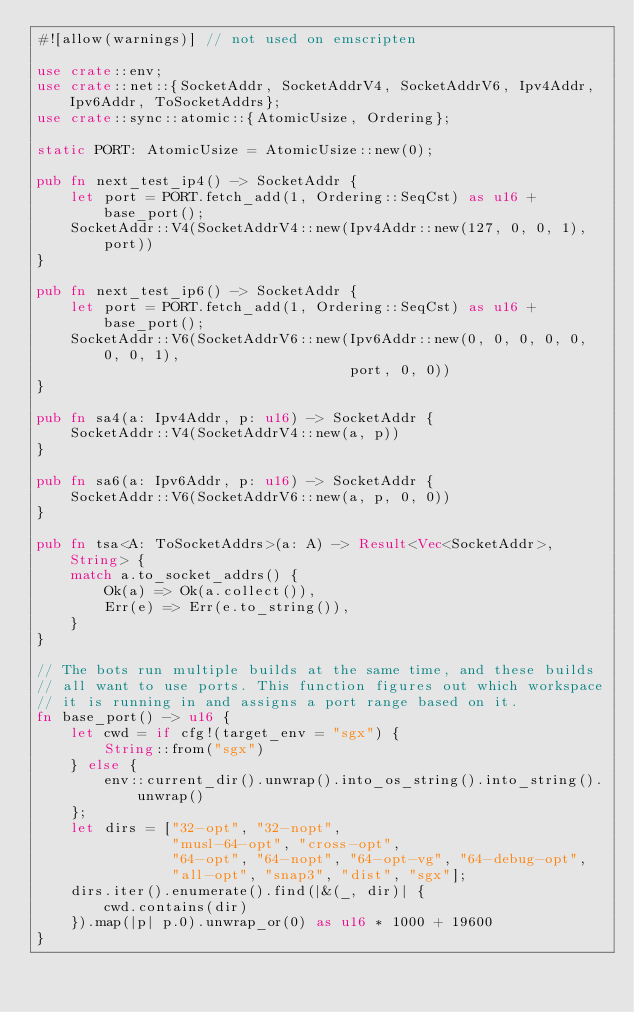Convert code to text. <code><loc_0><loc_0><loc_500><loc_500><_Rust_>#![allow(warnings)] // not used on emscripten

use crate::env;
use crate::net::{SocketAddr, SocketAddrV4, SocketAddrV6, Ipv4Addr, Ipv6Addr, ToSocketAddrs};
use crate::sync::atomic::{AtomicUsize, Ordering};

static PORT: AtomicUsize = AtomicUsize::new(0);

pub fn next_test_ip4() -> SocketAddr {
    let port = PORT.fetch_add(1, Ordering::SeqCst) as u16 + base_port();
    SocketAddr::V4(SocketAddrV4::new(Ipv4Addr::new(127, 0, 0, 1), port))
}

pub fn next_test_ip6() -> SocketAddr {
    let port = PORT.fetch_add(1, Ordering::SeqCst) as u16 + base_port();
    SocketAddr::V6(SocketAddrV6::new(Ipv6Addr::new(0, 0, 0, 0, 0, 0, 0, 1),
                                     port, 0, 0))
}

pub fn sa4(a: Ipv4Addr, p: u16) -> SocketAddr {
    SocketAddr::V4(SocketAddrV4::new(a, p))
}

pub fn sa6(a: Ipv6Addr, p: u16) -> SocketAddr {
    SocketAddr::V6(SocketAddrV6::new(a, p, 0, 0))
}

pub fn tsa<A: ToSocketAddrs>(a: A) -> Result<Vec<SocketAddr>, String> {
    match a.to_socket_addrs() {
        Ok(a) => Ok(a.collect()),
        Err(e) => Err(e.to_string()),
    }
}

// The bots run multiple builds at the same time, and these builds
// all want to use ports. This function figures out which workspace
// it is running in and assigns a port range based on it.
fn base_port() -> u16 {
    let cwd = if cfg!(target_env = "sgx") {
        String::from("sgx")
    } else {
        env::current_dir().unwrap().into_os_string().into_string().unwrap()
    };
    let dirs = ["32-opt", "32-nopt",
                "musl-64-opt", "cross-opt",
                "64-opt", "64-nopt", "64-opt-vg", "64-debug-opt",
                "all-opt", "snap3", "dist", "sgx"];
    dirs.iter().enumerate().find(|&(_, dir)| {
        cwd.contains(dir)
    }).map(|p| p.0).unwrap_or(0) as u16 * 1000 + 19600
}
</code> 